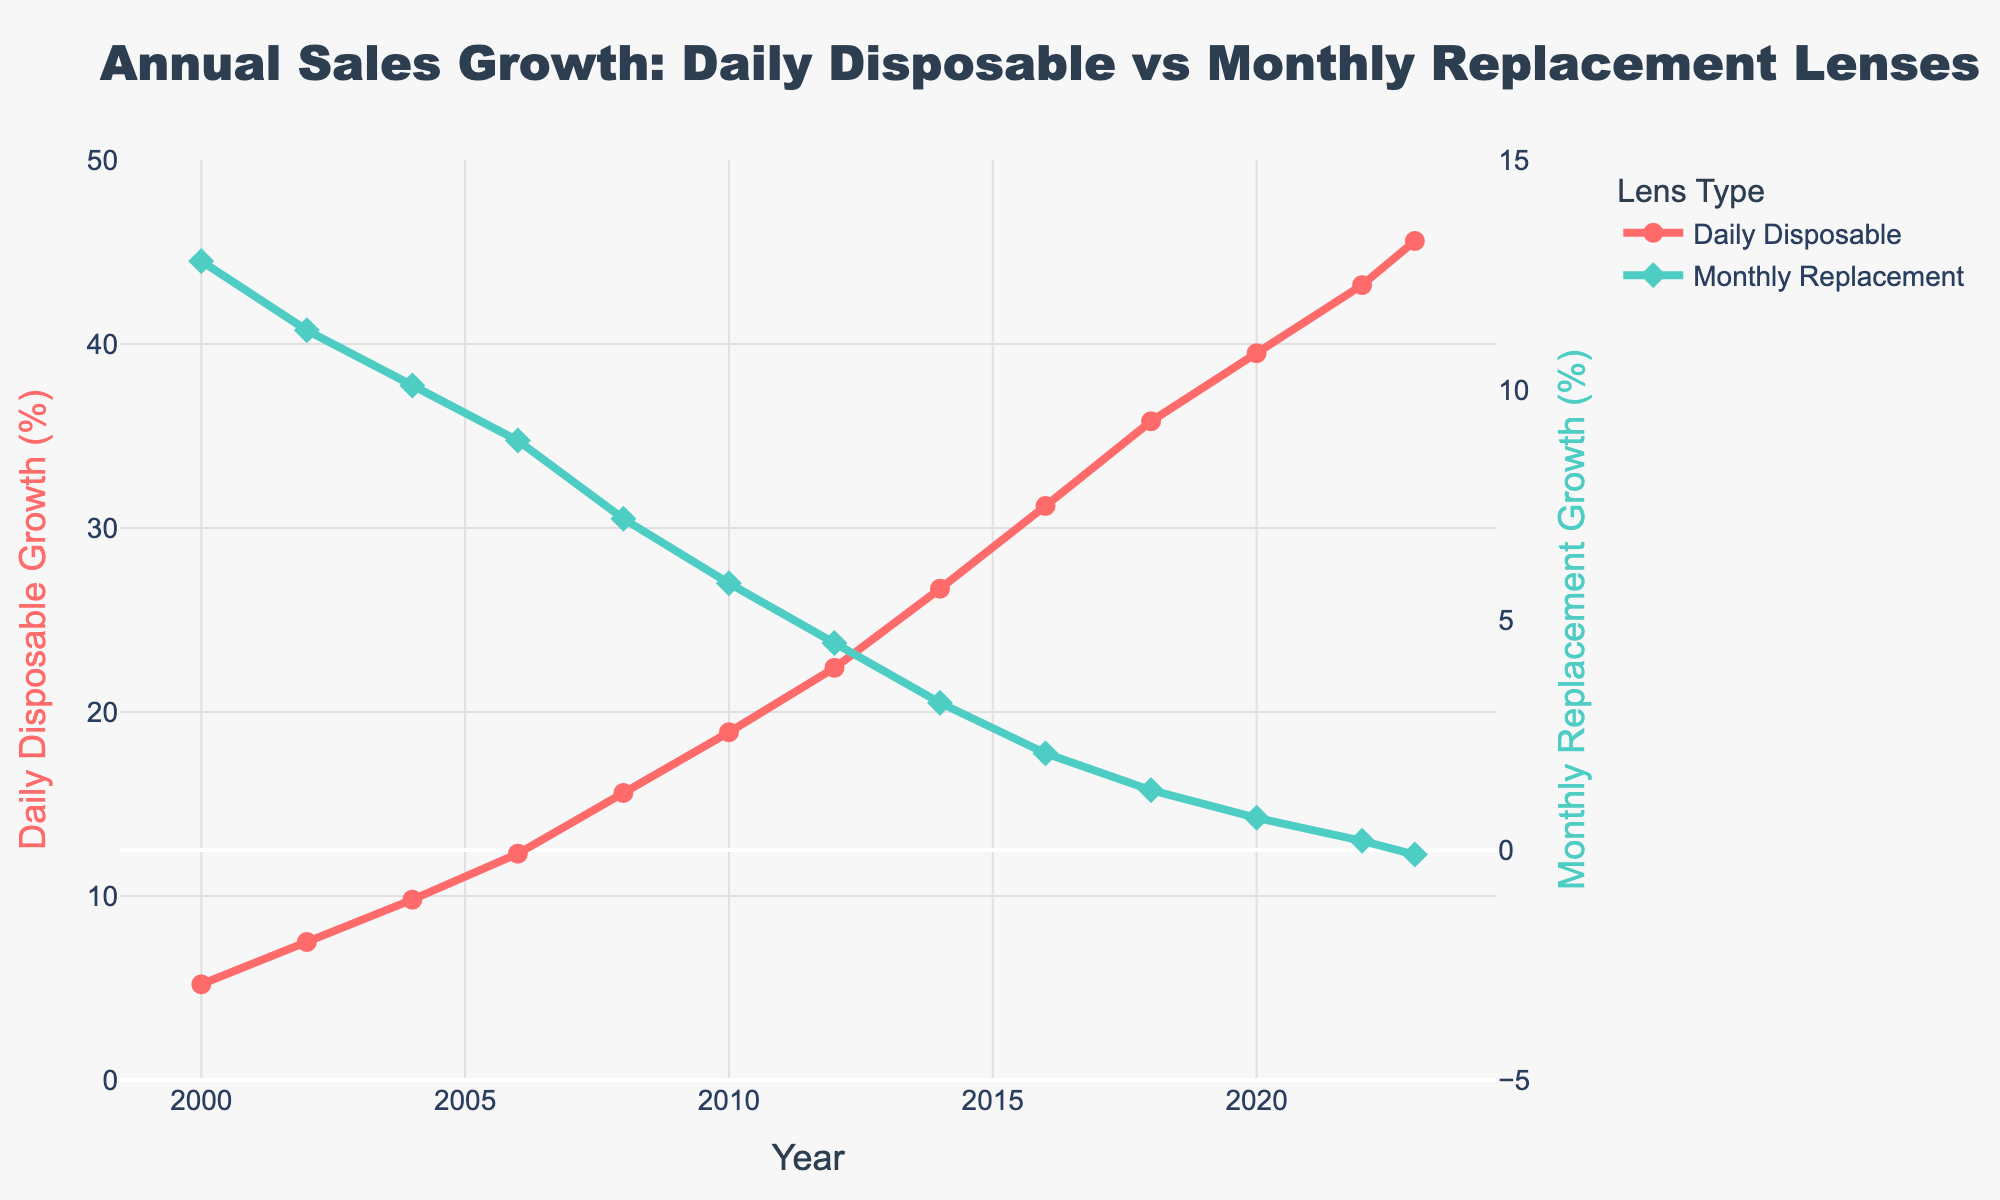What was the sales growth for Daily Disposable lenses in 2006? To find the sales growth for Daily Disposable lenses in 2006, look at the point on the "Daily Disposable" line that corresponds to the year 2006. The value is 12.3%.
Answer: 12.3% How does the sales growth of Monthly Replacement lenses in 2016 compare to 2000? Look at the points on the "Monthly Replacement" line for the years 2016 and 2000. The values are 2.1% and 12.8%, respectively. Compare these two values to see that 2016 has a much lower growth rate than 2000.
Answer: 2016 is much lower than 2000 What is the difference in sales growth between Daily Disposable and Monthly Replacement lenses in 2023? To find the difference, subtract the sales growth of Monthly Replacement lenses from Daily Disposable lenses in 2023. The values are 45.6% (Daily Disposable) and -0.1% (Monthly Replacement). So, 45.6 - (-0.1) = 45.7%.
Answer: 45.7% Which year shows the highest sales growth for Daily Disposable lenses? Scan through the "Daily Disposable" line to find the maximum value, which is 45.6% in the year 2023.
Answer: 2023 Is there a year when the sales growth of Monthly Replacement lenses became negative? Look at the "Monthly Replacement" line to identify if it drops below 0% at any point. In 2023, the value is -0.1%, indicating negative growth.
Answer: 2023 By how much did the sales growth of Daily Disposable lenses increase from 2000 to 2010? To find the increase, subtract the sales growth in 2000 from that in 2010. The values are 5.2% (2000) and 18.9% (2010). Thus, 18.9 - 5.2 = 13.7%.
Answer: 13.7% What can be said about the sales growth trend of Monthly Replacement lenses from 2000 to 2023? Observe the "Monthly Replacement" line from 2000 to 2023. The trend shows a continuous decline from 12.8% in 2000 to -0.1% in 2023.
Answer: Continuous decline Between 2012 and 2016, how does the sales growth of Daily Disposable lenses compare to that of Monthly Replacement lenses? Look at the values for both lens types in 2012 and 2016. For Daily Disposable lenses, the growth is 22.4% (2012) and 31.2% (2016). For Monthly Replacement lenses, the growth is 4.5% (2012) and 2.1% (2016). The growth of Daily Disposable lenses is higher and increasing, whereas that of Monthly Replacement lenses is lower and decreasing.
Answer: Daily Disposable is higher and increasing, Monthly Replacement is lower and decreasing What is the visual difference between the two data lines on the plot? The "Daily Disposable" line is represented by a red color and circle markers, showing increasing growth. The "Monthly Replacement" line is represented by a green color and diamond markers, showing decreasing growth.
Answer: Red circles increasing, green diamonds decreasing 